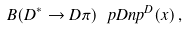<formula> <loc_0><loc_0><loc_500><loc_500>B ( D ^ { * } \to D \pi ) \, \ p D n p ^ { D } ( x ) \, ,</formula> 